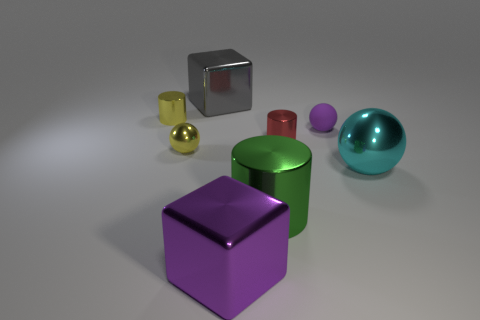Add 1 big gray things. How many objects exist? 9 Subtract all spheres. How many objects are left? 5 Add 5 red objects. How many red objects are left? 6 Add 4 large green cubes. How many large green cubes exist? 4 Subtract 0 yellow blocks. How many objects are left? 8 Subtract all green matte objects. Subtract all tiny purple matte balls. How many objects are left? 7 